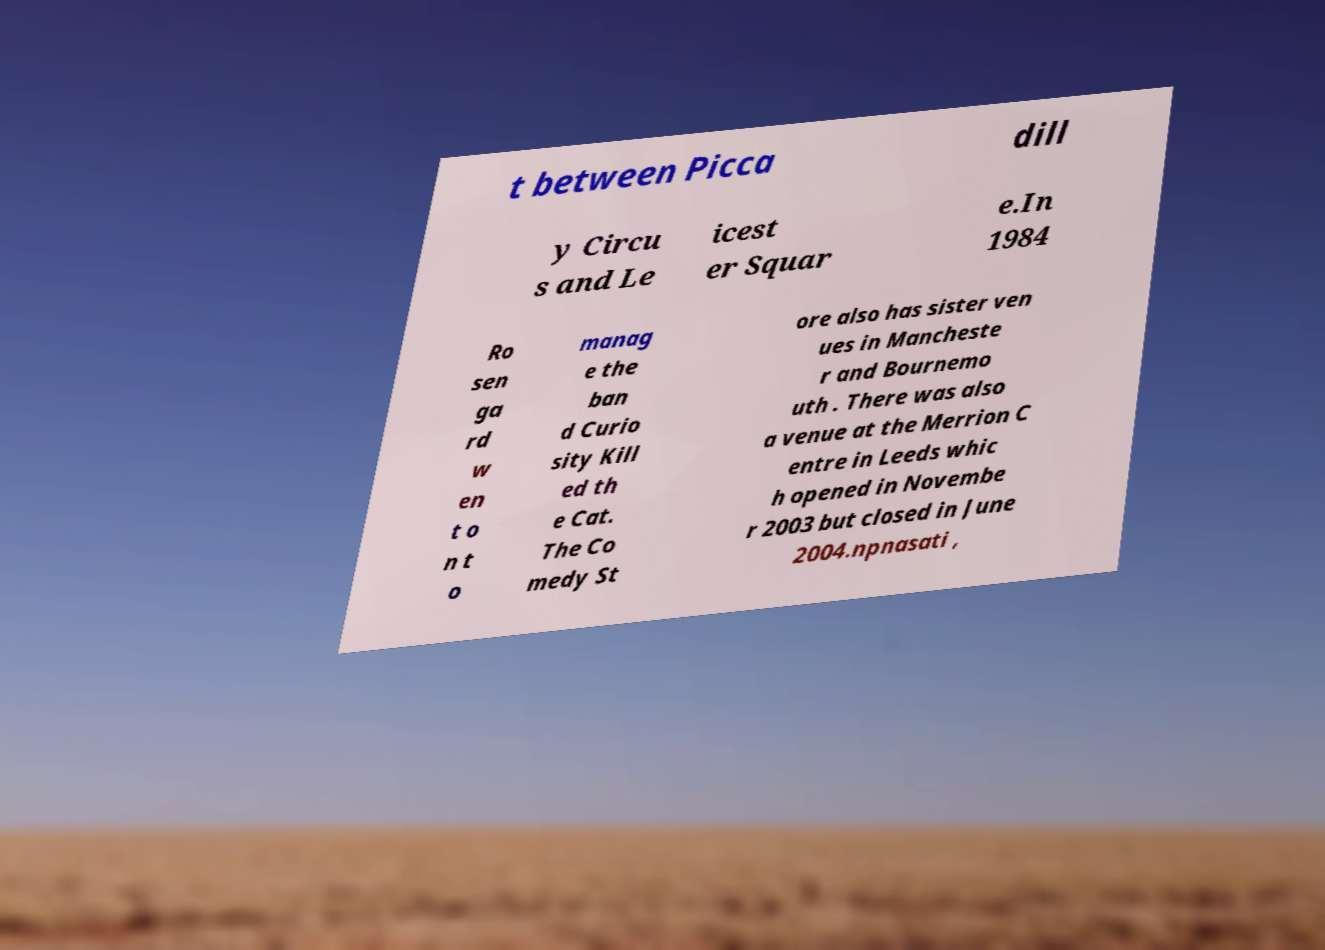For documentation purposes, I need the text within this image transcribed. Could you provide that? t between Picca dill y Circu s and Le icest er Squar e.In 1984 Ro sen ga rd w en t o n t o manag e the ban d Curio sity Kill ed th e Cat. The Co medy St ore also has sister ven ues in Mancheste r and Bournemo uth . There was also a venue at the Merrion C entre in Leeds whic h opened in Novembe r 2003 but closed in June 2004.npnasati , 